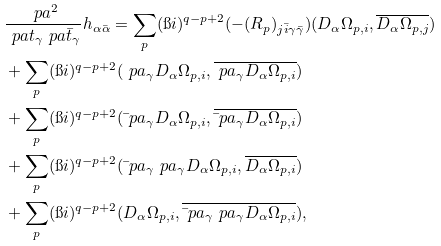Convert formula to latex. <formula><loc_0><loc_0><loc_500><loc_500>& \frac { \ p a ^ { 2 } } { \ p a t _ { \gamma } \ p a \bar { t } _ { \gamma } } h _ { \alpha \bar { \alpha } } = \sum _ { p } ( \i i ) ^ { q - p + 2 } ( - ( R _ { p } ) _ { j \bar { i } \gamma \bar { \gamma } } ) ( D _ { \alpha } \Omega _ { p , i } , \overline { D _ { \alpha } \Omega _ { p , j } } ) \\ & + \sum _ { p } ( \i i ) ^ { q - p + 2 } ( \ p a _ { \gamma } D _ { \alpha } \Omega _ { p , i } , \overline { \ p a _ { \gamma } D _ { \alpha } \Omega _ { p , i } } ) \\ & + \sum _ { p } ( \i i ) ^ { q - p + 2 } ( \bar { \ } p a _ { \gamma } D _ { \alpha } \Omega _ { p , i } , \overline { \bar { \ } p a _ { \gamma } D _ { \alpha } \Omega _ { p , i } } ) \\ & + \sum _ { p } ( \i i ) ^ { q - p + 2 } ( \bar { \ } p a _ { \gamma } \ p a _ { \gamma } D _ { \alpha } \Omega _ { p , i } , \overline { D _ { \alpha } \Omega _ { p , i } } ) \\ & + \sum _ { p } ( \i i ) ^ { q - p + 2 } ( D _ { \alpha } \Omega _ { p , i } , \overline { \bar { \ } p a _ { \gamma } \ p a _ { \gamma } D _ { \alpha } \Omega _ { p , i } } ) ,</formula> 